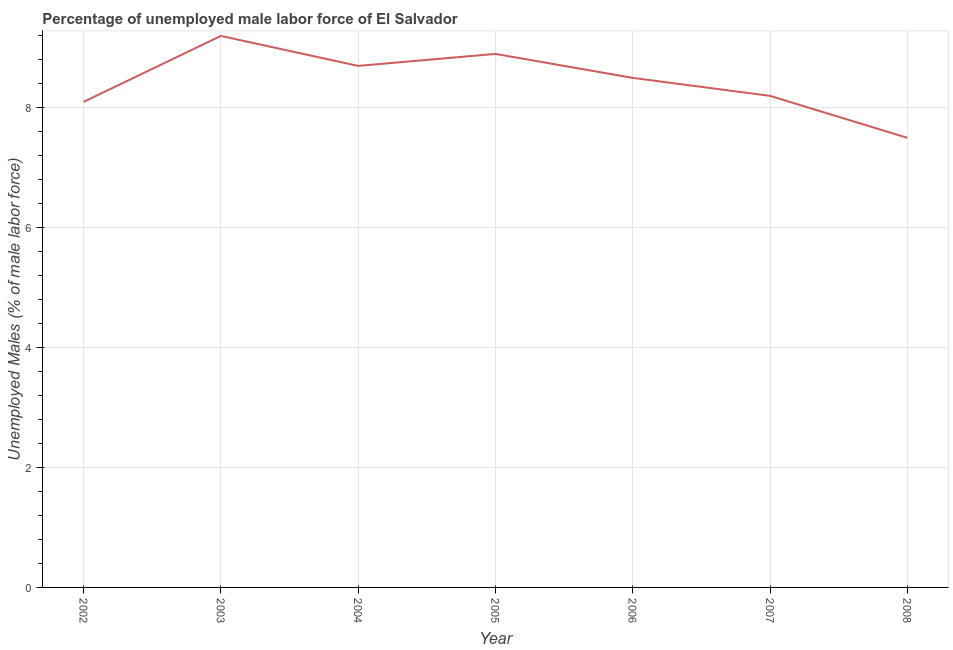What is the total unemployed male labour force in 2005?
Make the answer very short. 8.9. Across all years, what is the maximum total unemployed male labour force?
Make the answer very short. 9.2. In which year was the total unemployed male labour force minimum?
Ensure brevity in your answer.  2008. What is the sum of the total unemployed male labour force?
Offer a terse response. 59.1. What is the difference between the total unemployed male labour force in 2002 and 2004?
Your response must be concise. -0.6. What is the average total unemployed male labour force per year?
Provide a short and direct response. 8.44. What is the median total unemployed male labour force?
Offer a terse response. 8.5. What is the ratio of the total unemployed male labour force in 2003 to that in 2008?
Your response must be concise. 1.23. Is the total unemployed male labour force in 2004 less than that in 2007?
Provide a short and direct response. No. Is the difference between the total unemployed male labour force in 2002 and 2005 greater than the difference between any two years?
Offer a terse response. No. What is the difference between the highest and the second highest total unemployed male labour force?
Make the answer very short. 0.3. Is the sum of the total unemployed male labour force in 2002 and 2008 greater than the maximum total unemployed male labour force across all years?
Provide a short and direct response. Yes. What is the difference between the highest and the lowest total unemployed male labour force?
Provide a succinct answer. 1.7. In how many years, is the total unemployed male labour force greater than the average total unemployed male labour force taken over all years?
Offer a very short reply. 4. How many years are there in the graph?
Make the answer very short. 7. Are the values on the major ticks of Y-axis written in scientific E-notation?
Offer a terse response. No. What is the title of the graph?
Provide a succinct answer. Percentage of unemployed male labor force of El Salvador. What is the label or title of the Y-axis?
Your response must be concise. Unemployed Males (% of male labor force). What is the Unemployed Males (% of male labor force) of 2002?
Provide a succinct answer. 8.1. What is the Unemployed Males (% of male labor force) of 2003?
Keep it short and to the point. 9.2. What is the Unemployed Males (% of male labor force) in 2004?
Provide a short and direct response. 8.7. What is the Unemployed Males (% of male labor force) in 2005?
Your response must be concise. 8.9. What is the Unemployed Males (% of male labor force) of 2006?
Your response must be concise. 8.5. What is the Unemployed Males (% of male labor force) in 2007?
Provide a short and direct response. 8.2. What is the Unemployed Males (% of male labor force) in 2008?
Make the answer very short. 7.5. What is the difference between the Unemployed Males (% of male labor force) in 2002 and 2004?
Keep it short and to the point. -0.6. What is the difference between the Unemployed Males (% of male labor force) in 2002 and 2005?
Provide a succinct answer. -0.8. What is the difference between the Unemployed Males (% of male labor force) in 2002 and 2007?
Offer a very short reply. -0.1. What is the difference between the Unemployed Males (% of male labor force) in 2002 and 2008?
Provide a succinct answer. 0.6. What is the difference between the Unemployed Males (% of male labor force) in 2003 and 2005?
Provide a succinct answer. 0.3. What is the difference between the Unemployed Males (% of male labor force) in 2003 and 2006?
Offer a terse response. 0.7. What is the difference between the Unemployed Males (% of male labor force) in 2003 and 2008?
Your answer should be very brief. 1.7. What is the difference between the Unemployed Males (% of male labor force) in 2004 and 2005?
Your response must be concise. -0.2. What is the difference between the Unemployed Males (% of male labor force) in 2004 and 2007?
Your response must be concise. 0.5. What is the difference between the Unemployed Males (% of male labor force) in 2005 and 2006?
Your response must be concise. 0.4. What is the difference between the Unemployed Males (% of male labor force) in 2007 and 2008?
Ensure brevity in your answer.  0.7. What is the ratio of the Unemployed Males (% of male labor force) in 2002 to that in 2004?
Ensure brevity in your answer.  0.93. What is the ratio of the Unemployed Males (% of male labor force) in 2002 to that in 2005?
Ensure brevity in your answer.  0.91. What is the ratio of the Unemployed Males (% of male labor force) in 2002 to that in 2006?
Ensure brevity in your answer.  0.95. What is the ratio of the Unemployed Males (% of male labor force) in 2003 to that in 2004?
Your answer should be compact. 1.06. What is the ratio of the Unemployed Males (% of male labor force) in 2003 to that in 2005?
Provide a short and direct response. 1.03. What is the ratio of the Unemployed Males (% of male labor force) in 2003 to that in 2006?
Your answer should be very brief. 1.08. What is the ratio of the Unemployed Males (% of male labor force) in 2003 to that in 2007?
Your answer should be compact. 1.12. What is the ratio of the Unemployed Males (% of male labor force) in 2003 to that in 2008?
Your answer should be very brief. 1.23. What is the ratio of the Unemployed Males (% of male labor force) in 2004 to that in 2006?
Keep it short and to the point. 1.02. What is the ratio of the Unemployed Males (% of male labor force) in 2004 to that in 2007?
Ensure brevity in your answer.  1.06. What is the ratio of the Unemployed Males (% of male labor force) in 2004 to that in 2008?
Your answer should be very brief. 1.16. What is the ratio of the Unemployed Males (% of male labor force) in 2005 to that in 2006?
Give a very brief answer. 1.05. What is the ratio of the Unemployed Males (% of male labor force) in 2005 to that in 2007?
Make the answer very short. 1.08. What is the ratio of the Unemployed Males (% of male labor force) in 2005 to that in 2008?
Ensure brevity in your answer.  1.19. What is the ratio of the Unemployed Males (% of male labor force) in 2006 to that in 2007?
Give a very brief answer. 1.04. What is the ratio of the Unemployed Males (% of male labor force) in 2006 to that in 2008?
Keep it short and to the point. 1.13. What is the ratio of the Unemployed Males (% of male labor force) in 2007 to that in 2008?
Your answer should be very brief. 1.09. 